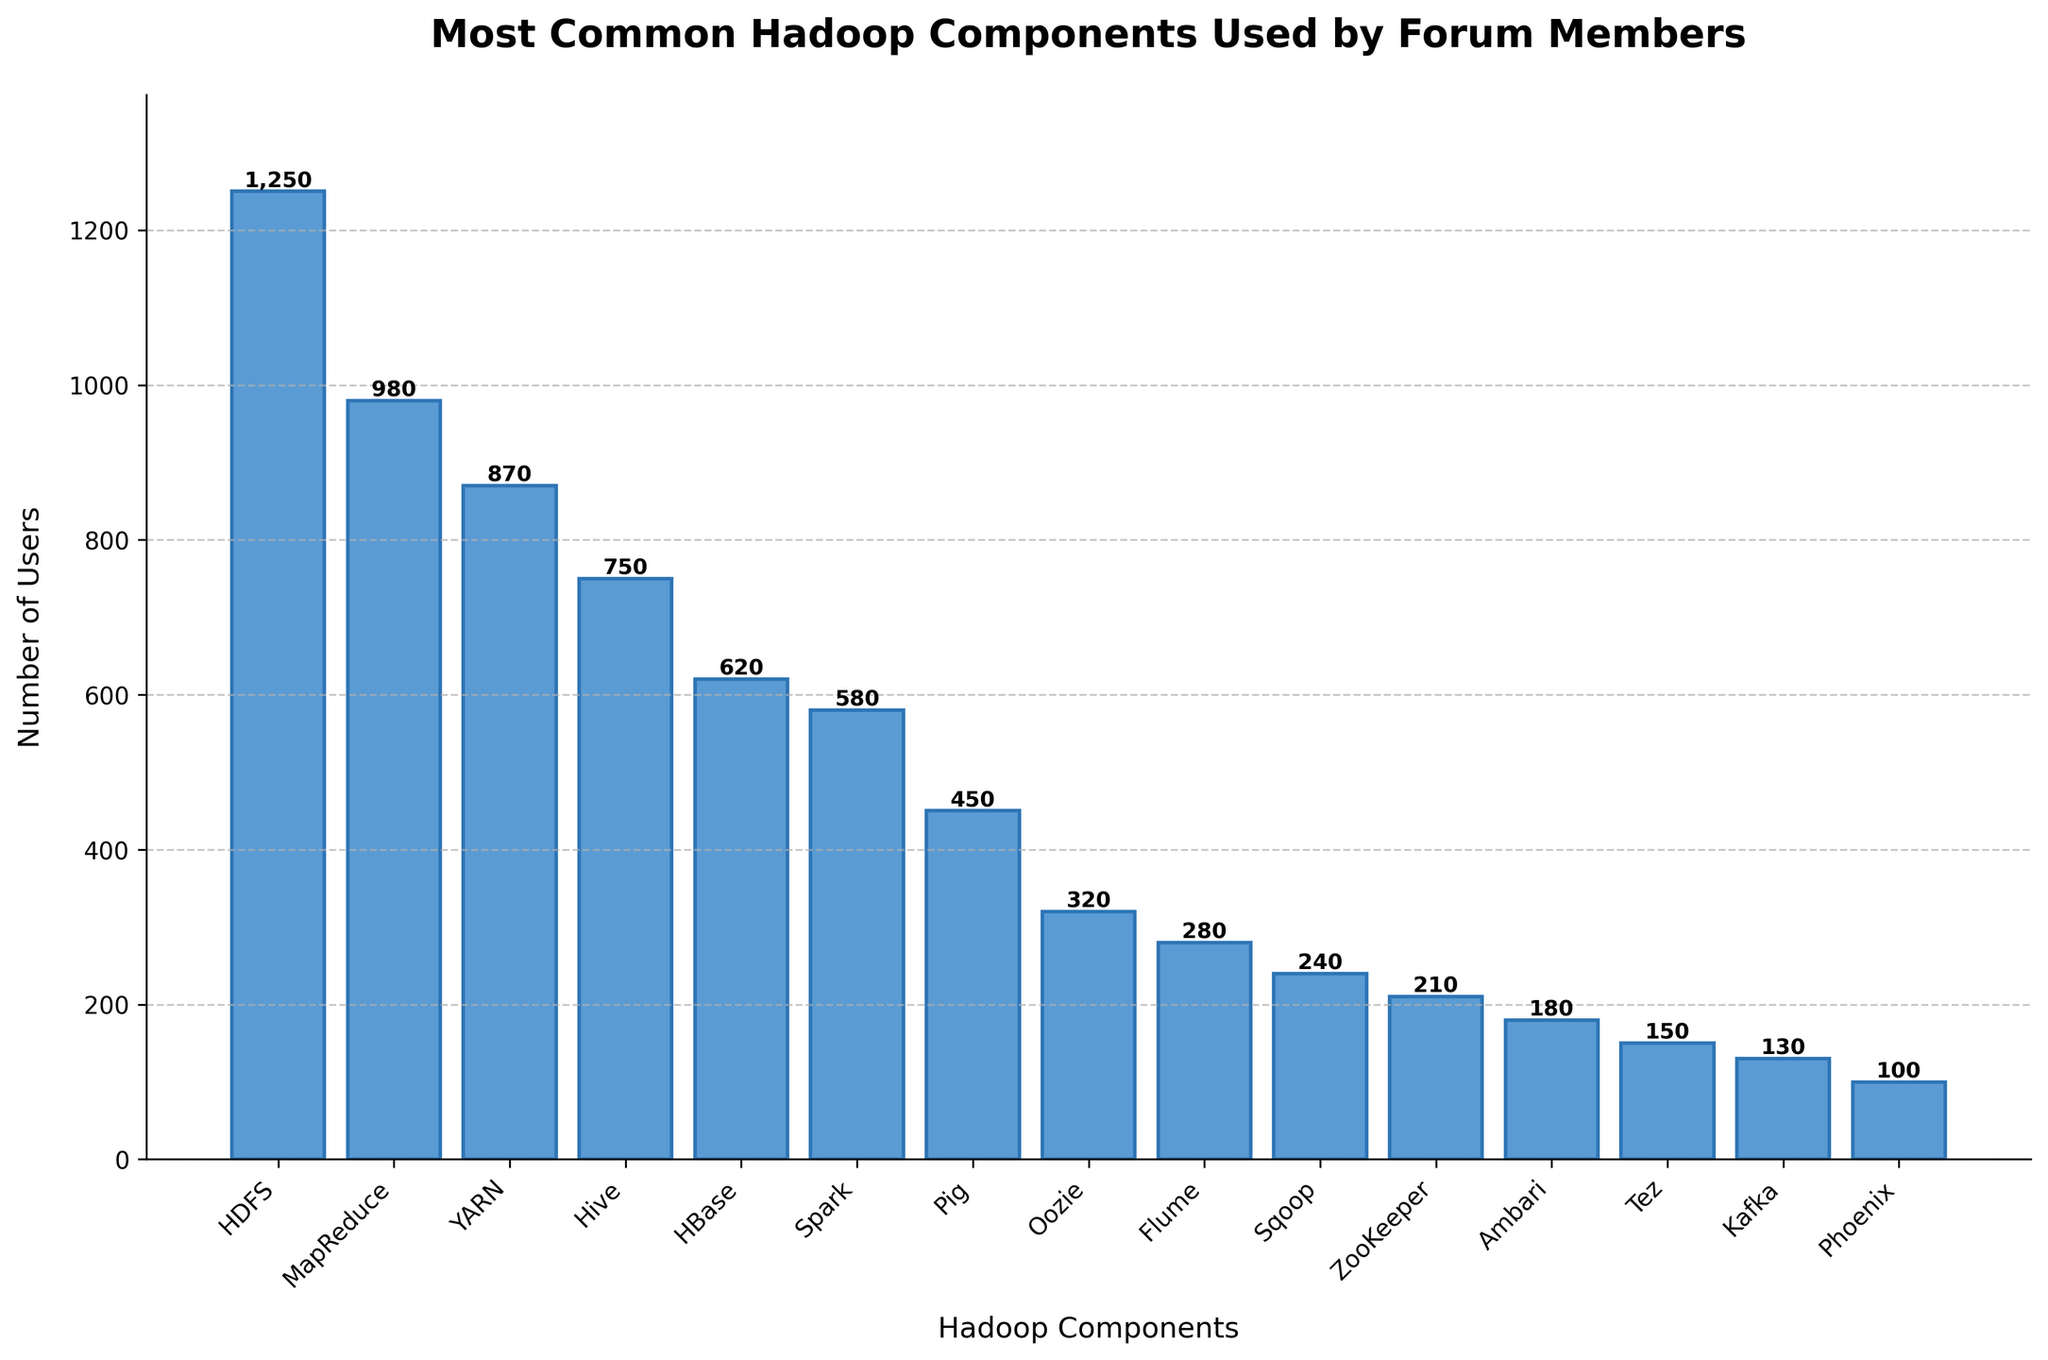Which Hadoop component is used by the most forum members? The height of each bar represents the number of users using each component. HDFS has the tallest bar, indicating that it is used by the most members.
Answer: HDFS How many more users use HDFS compared to MapReduce? Look at the heights of the bars for HDFS and MapReduce. HDFS has 1250 users, and MapReduce has 980 users. Subtract the number of MapReduce users from HDFS users (1250 - 980).
Answer: 270 Which Hadoop component has the fewest users? The bar with the smallest height represents the fewest users. Phoenix has the shortest bar with 100 users.
Answer: Phoenix What is the total number of users for Hive, HBase, and Spark combined? Add the number of users for each component. Hive has 750 users, HBase has 620 users, and Spark has 580 users. The total is 750 + 620 + 580.
Answer: 1950 Is the number of users for Pig greater than or less than the number of users for Oozie? Compare the heights of the bars for Pig and Oozie. Pig has 450 users, while Oozie has 320 users. Therefore, Pig has more users than Oozie.
Answer: Greater than What is the difference in the number of users between ZooKeeper and Ambari? ZooKeeper has 210 users, and Ambari has 180 users. Subtract the number of Ambari users from ZooKeeper users (210 - 180).
Answer: 30 Which three components have the highest number of users, and what are their total number of users? Identify the three tallest bars, which correspond to HDFS, MapReduce, and YARN. HDFS has 1250 users, MapReduce has 980 users, and YARN has 870 users. Add these numbers together (1250 + 980 + 870).
Answer: 3100 Are there more users of Flume or Sqoop? Compare the heights of the bars for Flume and Sqoop. Flume has 280 users, and Sqoop has 240 users. Therefore, Flume has more users than Sqoop.
Answer: Flume How many users in total use components with fewer than 300 users? Identify the components with bars representing fewer than 300 users: Oozie (320- falls within), Flume (280), Sqoop (240), ZooKeeper (210), Ambari (180), Tez (150), Kafka (130), Phoenix (100). Sum these user numbers (280 + 240 + 210 + 180 + 150 + 130 + 100).
Answer: 1290 What is the median number of users for all the components? List out the number of users for all components in ascending order: (100, 130, 150, 180, 210, 240, 280, 320, 450, 580, 620, 750, 870, 980, 1250). Since there are 15 components, the median is the 8th value in this ordered list.
Answer: 320 